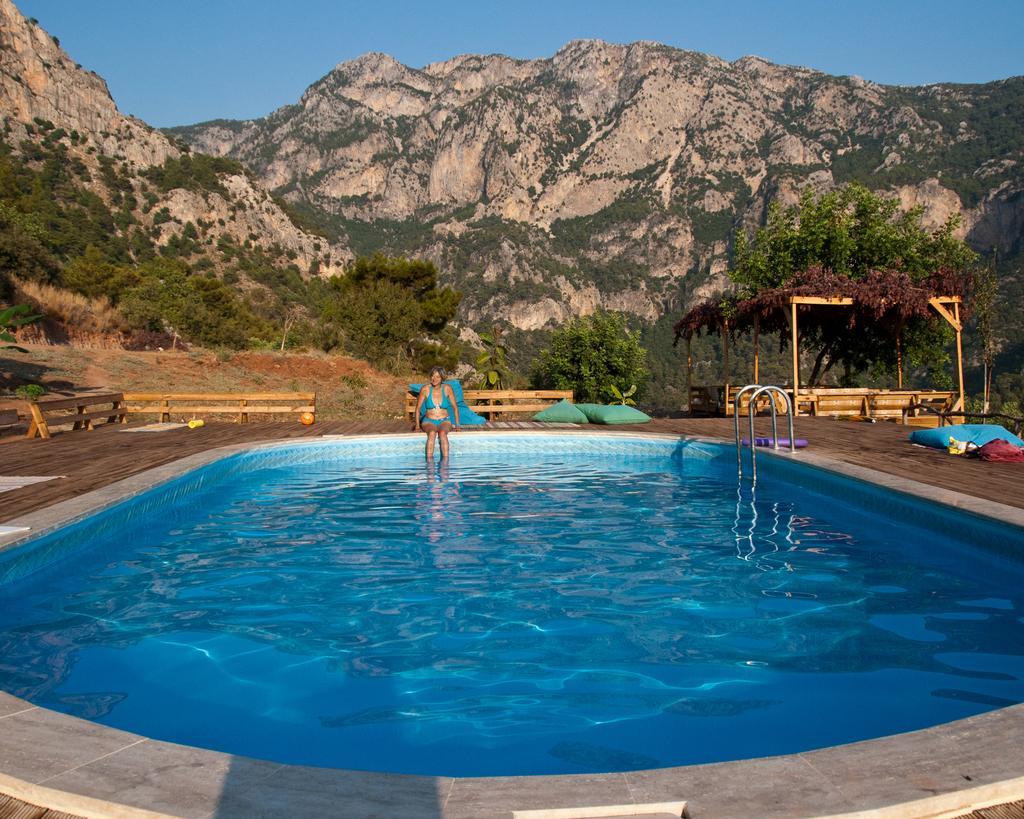Can you describe this image briefly? Here I can see a swimming pool. In the background a woman is sitting on the floor. Around the pool I can see few benches. In the background there are some trees and hills. At the top of the image I can see the sky. 